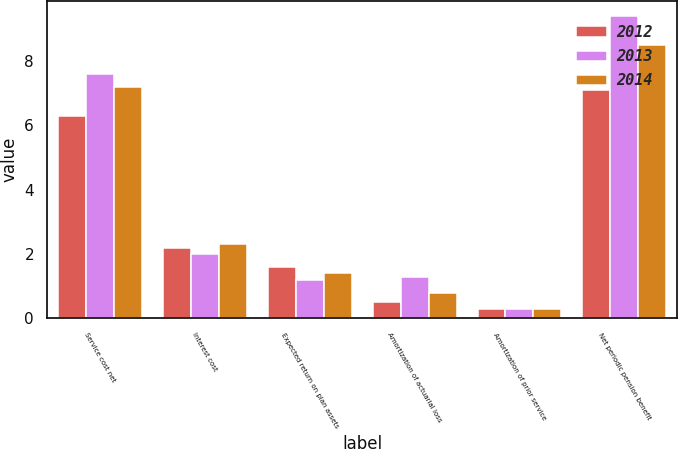<chart> <loc_0><loc_0><loc_500><loc_500><stacked_bar_chart><ecel><fcel>Service cost net<fcel>Interest cost<fcel>Expected return on plan assets<fcel>Amortization of actuarial loss<fcel>Amortization of prior service<fcel>Net periodic pension benefit<nl><fcel>2012<fcel>6.3<fcel>2.2<fcel>1.6<fcel>0.5<fcel>0.3<fcel>7.1<nl><fcel>2013<fcel>7.6<fcel>2<fcel>1.2<fcel>1.3<fcel>0.3<fcel>9.4<nl><fcel>2014<fcel>7.2<fcel>2.3<fcel>1.4<fcel>0.8<fcel>0.3<fcel>8.5<nl></chart> 